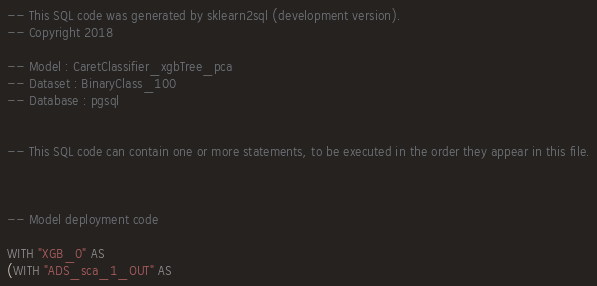Convert code to text. <code><loc_0><loc_0><loc_500><loc_500><_SQL_>-- This SQL code was generated by sklearn2sql (development version).
-- Copyright 2018

-- Model : CaretClassifier_xgbTree_pca
-- Dataset : BinaryClass_100
-- Database : pgsql


-- This SQL code can contain one or more statements, to be executed in the order they appear in this file.



-- Model deployment code

WITH "XGB_0" AS 
(WITH "ADS_sca_1_OUT" AS </code> 